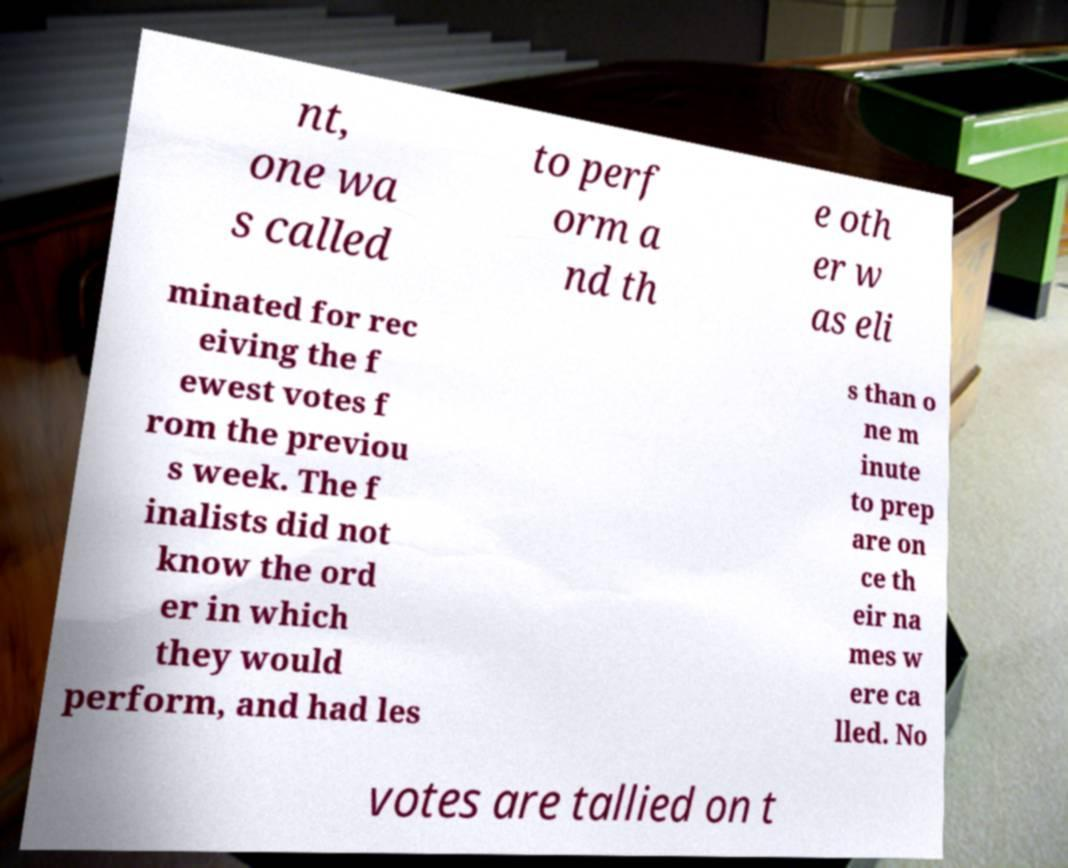For documentation purposes, I need the text within this image transcribed. Could you provide that? nt, one wa s called to perf orm a nd th e oth er w as eli minated for rec eiving the f ewest votes f rom the previou s week. The f inalists did not know the ord er in which they would perform, and had les s than o ne m inute to prep are on ce th eir na mes w ere ca lled. No votes are tallied on t 